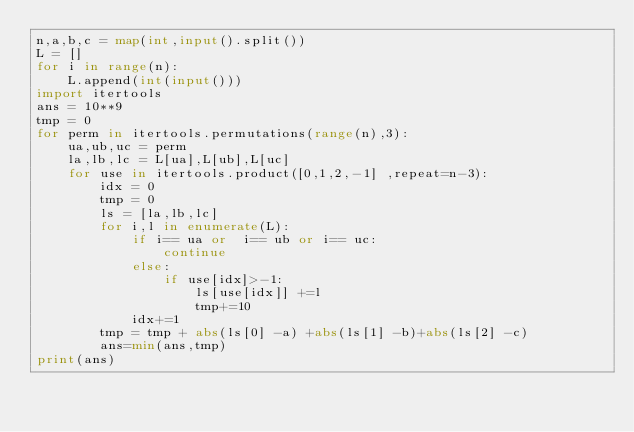Convert code to text. <code><loc_0><loc_0><loc_500><loc_500><_Python_>n,a,b,c = map(int,input().split())
L = []
for i in range(n):
    L.append(int(input()))
import itertools
ans = 10**9
tmp = 0
for perm in itertools.permutations(range(n),3):
    ua,ub,uc = perm
    la,lb,lc = L[ua],L[ub],L[uc]
    for use in itertools.product([0,1,2,-1] ,repeat=n-3):
        idx = 0
        tmp = 0
        ls = [la,lb,lc]
        for i,l in enumerate(L):
            if i== ua or  i== ub or i== uc:
                continue
            else:
                if use[idx]>-1:
                    ls[use[idx]] +=l
                    tmp+=10
            idx+=1
        tmp = tmp + abs(ls[0] -a) +abs(ls[1] -b)+abs(ls[2] -c)
        ans=min(ans,tmp)
print(ans)
</code> 